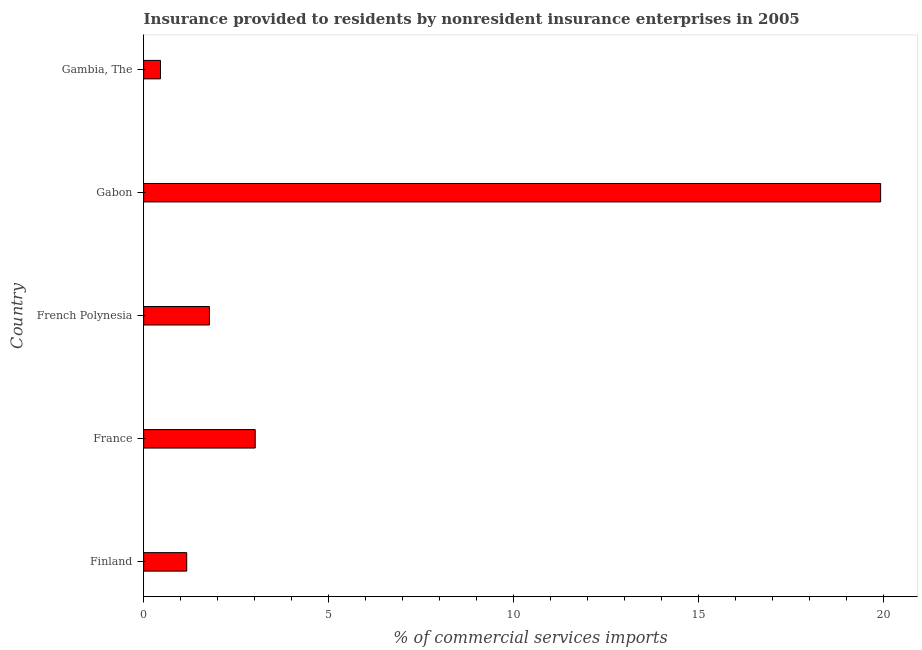Does the graph contain any zero values?
Offer a very short reply. No. What is the title of the graph?
Your answer should be very brief. Insurance provided to residents by nonresident insurance enterprises in 2005. What is the label or title of the X-axis?
Give a very brief answer. % of commercial services imports. What is the label or title of the Y-axis?
Provide a succinct answer. Country. What is the insurance provided by non-residents in Finland?
Offer a very short reply. 1.16. Across all countries, what is the maximum insurance provided by non-residents?
Give a very brief answer. 19.93. Across all countries, what is the minimum insurance provided by non-residents?
Your response must be concise. 0.46. In which country was the insurance provided by non-residents maximum?
Your answer should be very brief. Gabon. In which country was the insurance provided by non-residents minimum?
Your answer should be very brief. Gambia, The. What is the sum of the insurance provided by non-residents?
Provide a succinct answer. 26.35. What is the difference between the insurance provided by non-residents in French Polynesia and Gambia, The?
Ensure brevity in your answer.  1.32. What is the average insurance provided by non-residents per country?
Provide a short and direct response. 5.27. What is the median insurance provided by non-residents?
Offer a very short reply. 1.78. In how many countries, is the insurance provided by non-residents greater than 2 %?
Offer a terse response. 2. What is the ratio of the insurance provided by non-residents in French Polynesia to that in Gabon?
Give a very brief answer. 0.09. Is the insurance provided by non-residents in Finland less than that in France?
Your response must be concise. Yes. Is the difference between the insurance provided by non-residents in France and Gabon greater than the difference between any two countries?
Your answer should be very brief. No. What is the difference between the highest and the second highest insurance provided by non-residents?
Give a very brief answer. 16.91. Is the sum of the insurance provided by non-residents in Gabon and Gambia, The greater than the maximum insurance provided by non-residents across all countries?
Ensure brevity in your answer.  Yes. What is the difference between the highest and the lowest insurance provided by non-residents?
Provide a short and direct response. 19.48. How many bars are there?
Provide a succinct answer. 5. Are the values on the major ticks of X-axis written in scientific E-notation?
Ensure brevity in your answer.  No. What is the % of commercial services imports in Finland?
Provide a short and direct response. 1.16. What is the % of commercial services imports of France?
Provide a succinct answer. 3.02. What is the % of commercial services imports of French Polynesia?
Give a very brief answer. 1.78. What is the % of commercial services imports of Gabon?
Provide a succinct answer. 19.93. What is the % of commercial services imports in Gambia, The?
Your answer should be compact. 0.46. What is the difference between the % of commercial services imports in Finland and France?
Keep it short and to the point. -1.85. What is the difference between the % of commercial services imports in Finland and French Polynesia?
Make the answer very short. -0.61. What is the difference between the % of commercial services imports in Finland and Gabon?
Offer a very short reply. -18.77. What is the difference between the % of commercial services imports in Finland and Gambia, The?
Give a very brief answer. 0.71. What is the difference between the % of commercial services imports in France and French Polynesia?
Make the answer very short. 1.24. What is the difference between the % of commercial services imports in France and Gabon?
Provide a short and direct response. -16.91. What is the difference between the % of commercial services imports in France and Gambia, The?
Offer a very short reply. 2.56. What is the difference between the % of commercial services imports in French Polynesia and Gabon?
Give a very brief answer. -18.15. What is the difference between the % of commercial services imports in French Polynesia and Gambia, The?
Your answer should be compact. 1.32. What is the difference between the % of commercial services imports in Gabon and Gambia, The?
Your response must be concise. 19.48. What is the ratio of the % of commercial services imports in Finland to that in France?
Your response must be concise. 0.39. What is the ratio of the % of commercial services imports in Finland to that in French Polynesia?
Your response must be concise. 0.66. What is the ratio of the % of commercial services imports in Finland to that in Gabon?
Give a very brief answer. 0.06. What is the ratio of the % of commercial services imports in Finland to that in Gambia, The?
Keep it short and to the point. 2.56. What is the ratio of the % of commercial services imports in France to that in French Polynesia?
Your response must be concise. 1.7. What is the ratio of the % of commercial services imports in France to that in Gabon?
Your response must be concise. 0.15. What is the ratio of the % of commercial services imports in France to that in Gambia, The?
Your answer should be very brief. 6.62. What is the ratio of the % of commercial services imports in French Polynesia to that in Gabon?
Your response must be concise. 0.09. What is the ratio of the % of commercial services imports in French Polynesia to that in Gambia, The?
Offer a very short reply. 3.9. What is the ratio of the % of commercial services imports in Gabon to that in Gambia, The?
Your answer should be very brief. 43.76. 